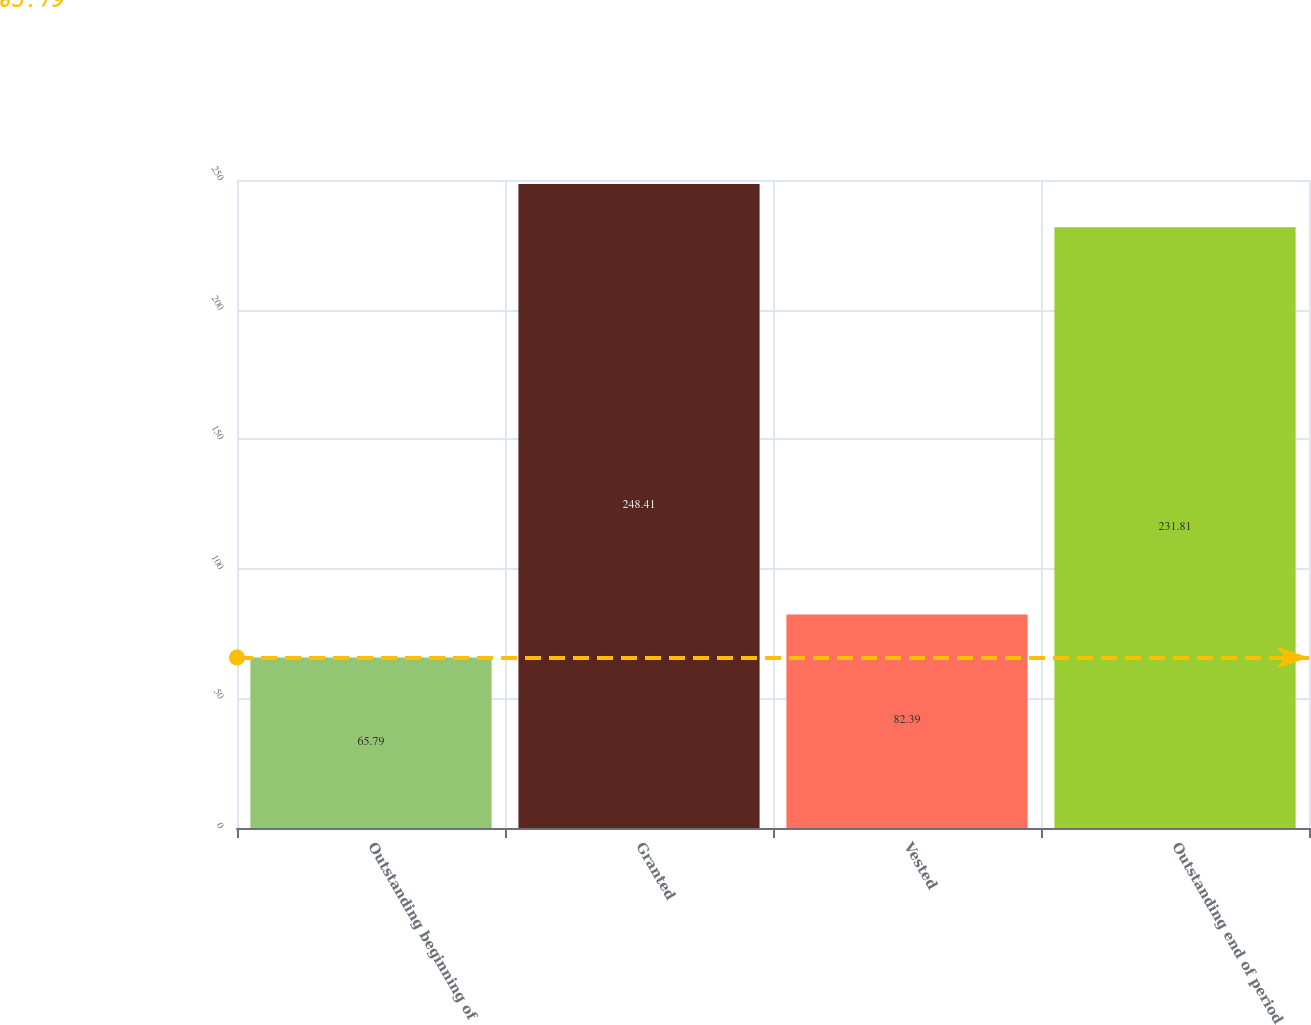<chart> <loc_0><loc_0><loc_500><loc_500><bar_chart><fcel>Outstanding beginning of<fcel>Granted<fcel>Vested<fcel>Outstanding end of period<nl><fcel>65.79<fcel>248.41<fcel>82.39<fcel>231.81<nl></chart> 